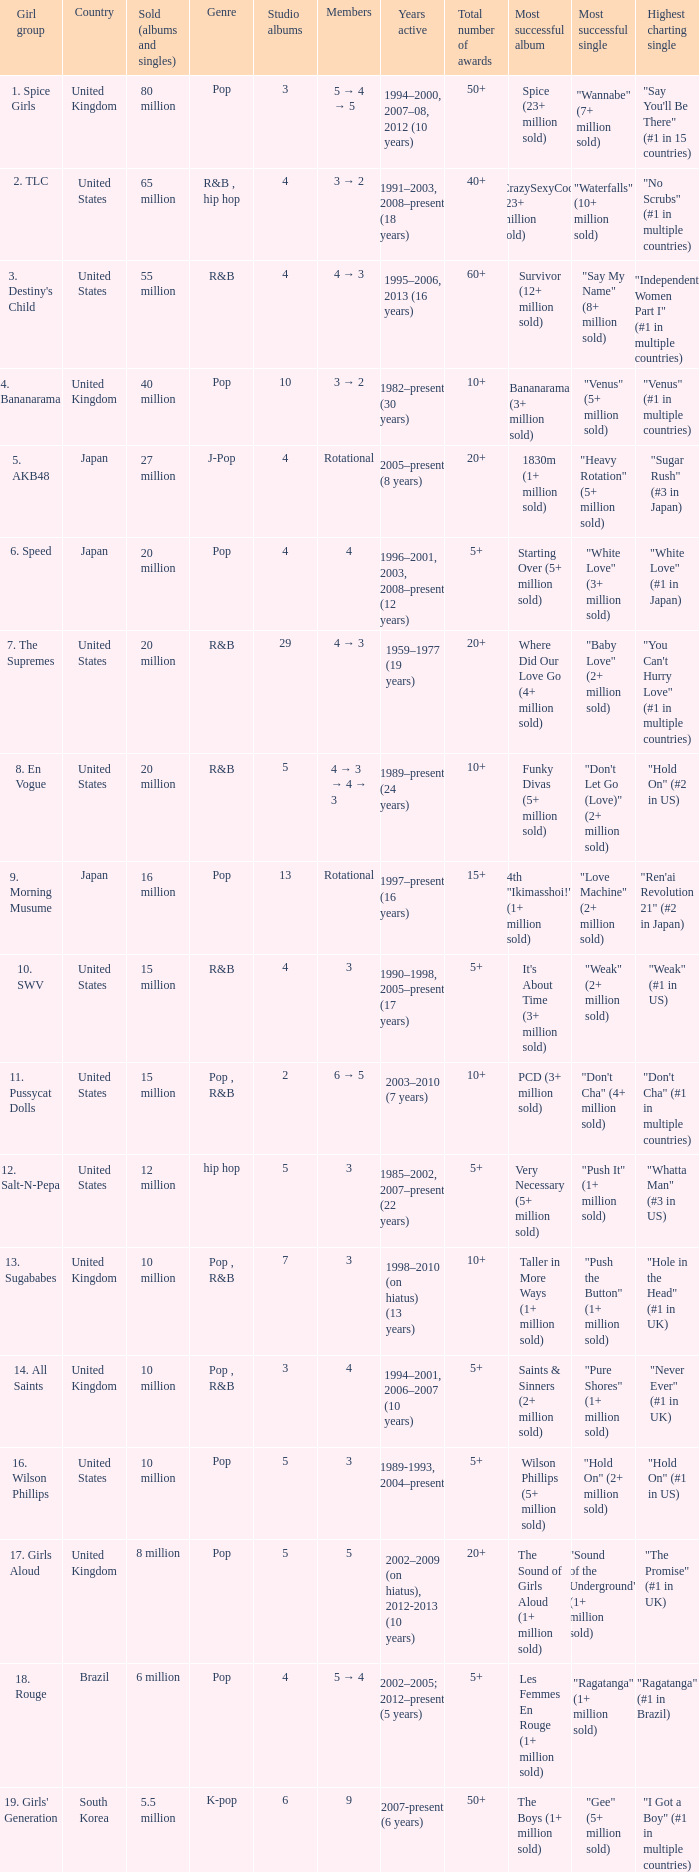What group had 29 studio albums? 7. The Supremes. 